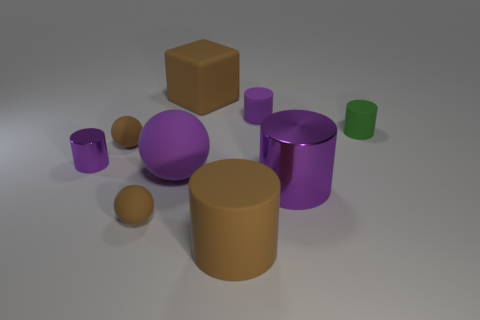Subtract all purple cylinders. How many were subtracted if there are1purple cylinders left? 2 Subtract all green spheres. How many purple cylinders are left? 3 Subtract all green cylinders. How many cylinders are left? 4 Subtract all brown cylinders. How many cylinders are left? 4 Subtract all gray cylinders. Subtract all yellow balls. How many cylinders are left? 5 Add 1 purple balls. How many objects exist? 10 Subtract all cylinders. How many objects are left? 4 Add 5 large purple balls. How many large purple balls are left? 6 Add 5 big blue things. How many big blue things exist? 5 Subtract 0 red cylinders. How many objects are left? 9 